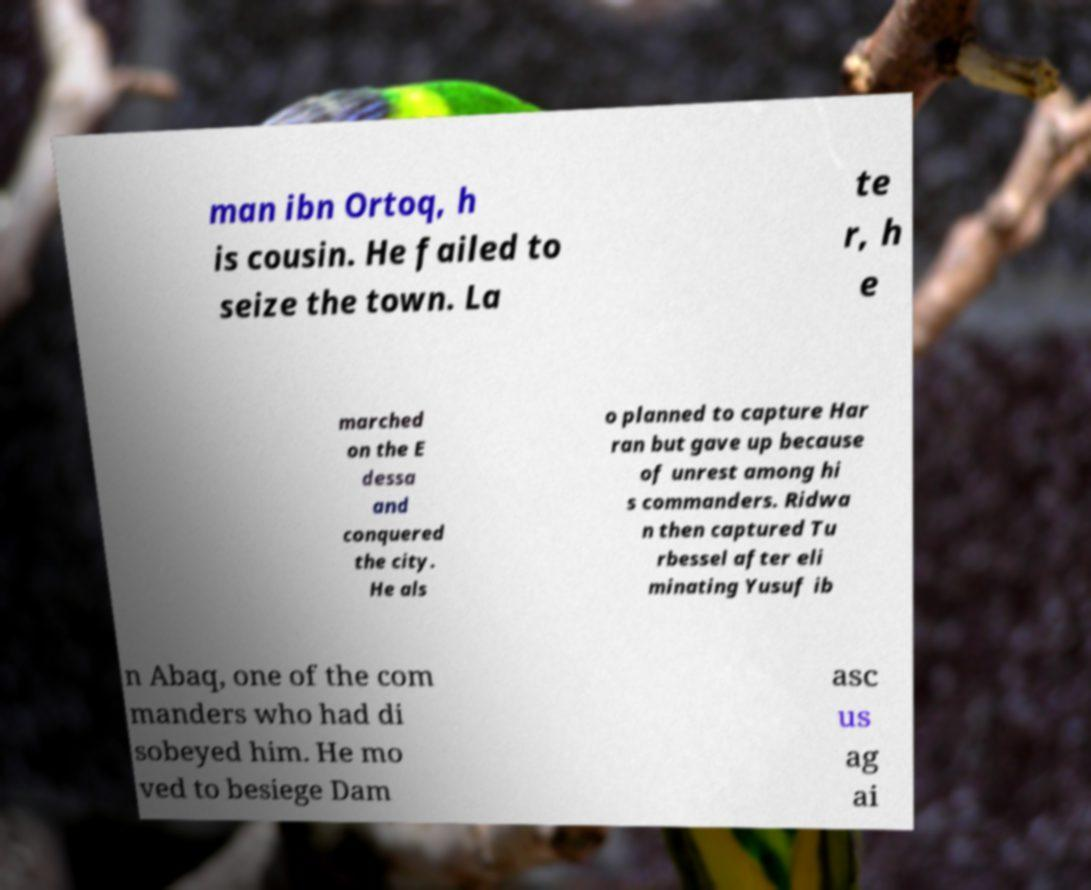Can you accurately transcribe the text from the provided image for me? man ibn Ortoq, h is cousin. He failed to seize the town. La te r, h e marched on the E dessa and conquered the city. He als o planned to capture Har ran but gave up because of unrest among hi s commanders. Ridwa n then captured Tu rbessel after eli minating Yusuf ib n Abaq, one of the com manders who had di sobeyed him. He mo ved to besiege Dam asc us ag ai 